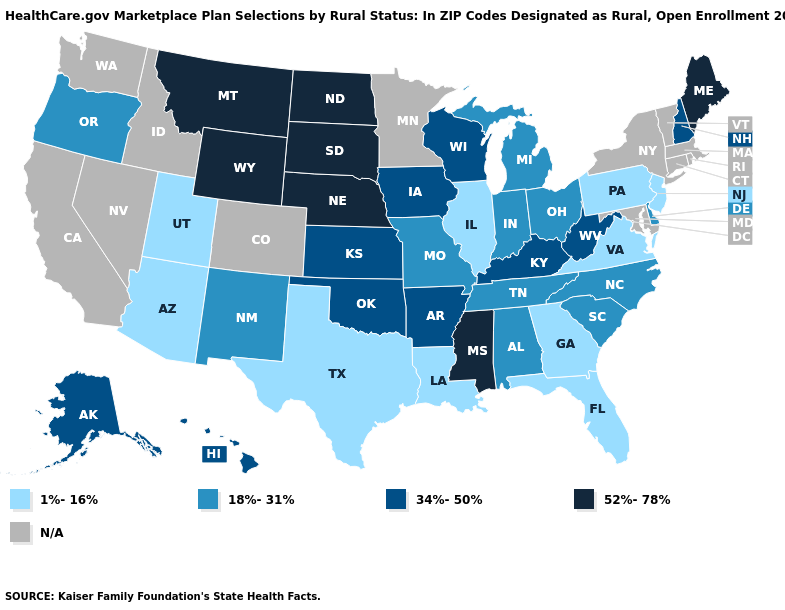What is the value of Arizona?
Answer briefly. 1%-16%. Does Kentucky have the lowest value in the USA?
Be succinct. No. Which states have the lowest value in the MidWest?
Be succinct. Illinois. What is the highest value in states that border Colorado?
Write a very short answer. 52%-78%. Does Utah have the lowest value in the USA?
Give a very brief answer. Yes. Does the first symbol in the legend represent the smallest category?
Answer briefly. Yes. What is the lowest value in states that border Massachusetts?
Quick response, please. 34%-50%. What is the value of Kansas?
Answer briefly. 34%-50%. Name the states that have a value in the range N/A?
Answer briefly. California, Colorado, Connecticut, Idaho, Maryland, Massachusetts, Minnesota, Nevada, New York, Rhode Island, Vermont, Washington. What is the value of Wyoming?
Quick response, please. 52%-78%. 